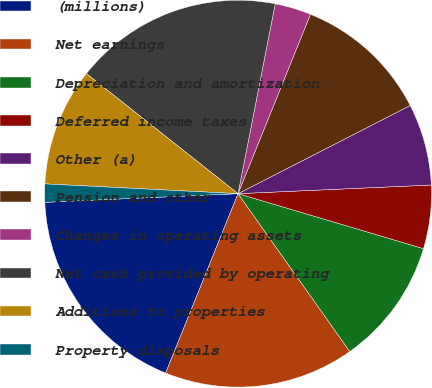Convert chart. <chart><loc_0><loc_0><loc_500><loc_500><pie_chart><fcel>(millions)<fcel>Net earnings<fcel>Depreciation and amortization<fcel>Deferred income taxes<fcel>Other (a)<fcel>Pension and other<fcel>Changes in operating assets<fcel>Net cash provided by operating<fcel>Additions to properties<fcel>Property disposals<nl><fcel>18.18%<fcel>15.91%<fcel>10.61%<fcel>5.3%<fcel>6.82%<fcel>11.36%<fcel>3.03%<fcel>17.42%<fcel>9.85%<fcel>1.52%<nl></chart> 